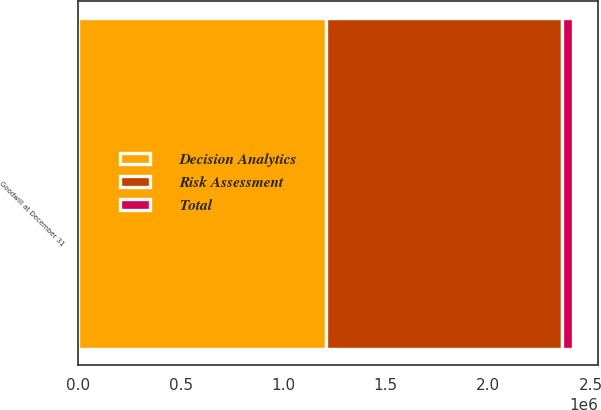Convert chart to OTSL. <chart><loc_0><loc_0><loc_500><loc_500><stacked_bar_chart><ecel><fcel>Goodwill at December 31<nl><fcel>Total<fcel>55555<nl><fcel>Risk Assessment<fcel>1.15159e+06<nl><fcel>Decision Analytics<fcel>1.20715e+06<nl></chart> 